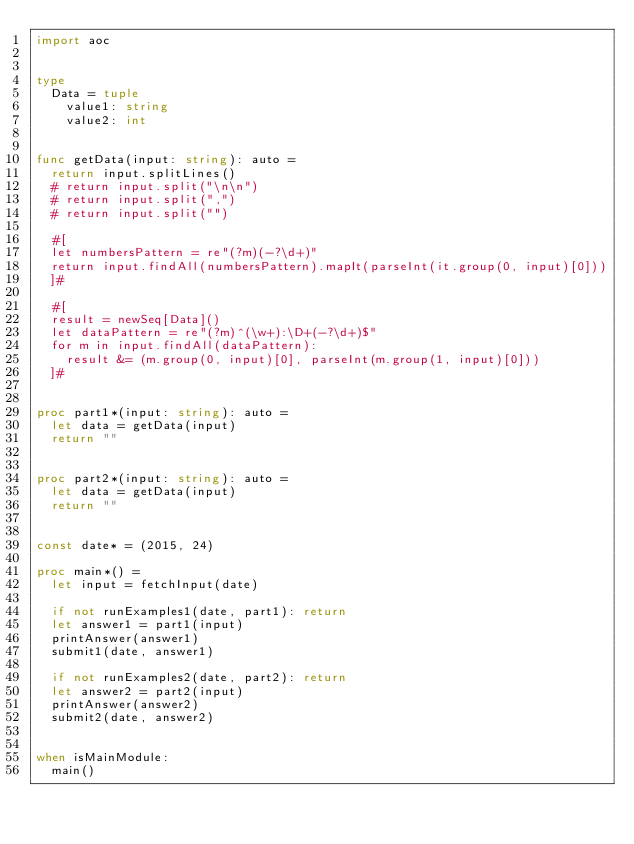Convert code to text. <code><loc_0><loc_0><loc_500><loc_500><_Nim_>import aoc


type
  Data = tuple
    value1: string
    value2: int


func getData(input: string): auto =
  return input.splitLines()
  # return input.split("\n\n")
  # return input.split(",")
  # return input.split("")

  #[
  let numbersPattern = re"(?m)(-?\d+)"
  return input.findAll(numbersPattern).mapIt(parseInt(it.group(0, input)[0]))
  ]#

  #[
  result = newSeq[Data]()
  let dataPattern = re"(?m)^(\w+):\D+(-?\d+)$"
  for m in input.findAll(dataPattern):
    result &= (m.group(0, input)[0], parseInt(m.group(1, input)[0]))
  ]#


proc part1*(input: string): auto =
  let data = getData(input)
  return ""


proc part2*(input: string): auto =
  let data = getData(input)
  return ""


const date* = (2015, 24)

proc main*() =
  let input = fetchInput(date)

  if not runExamples1(date, part1): return
  let answer1 = part1(input)
  printAnswer(answer1)
  submit1(date, answer1)

  if not runExamples2(date, part2): return
  let answer2 = part2(input)
  printAnswer(answer2)
  submit2(date, answer2)


when isMainModule:
  main()
</code> 